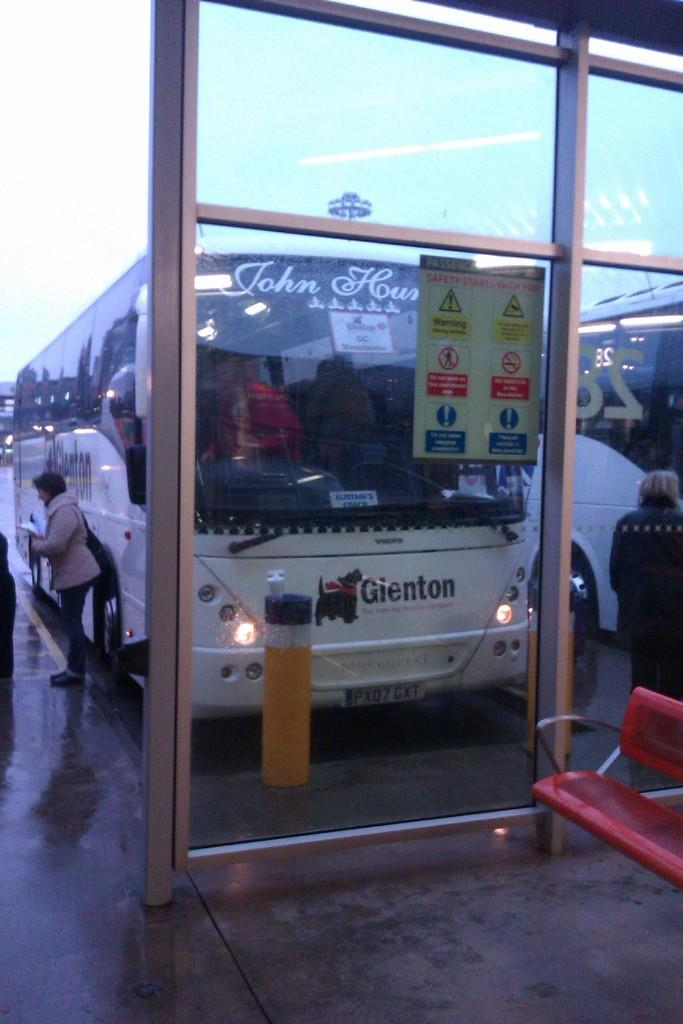What can be found in the parking space in the image? There are vehicles in the parking space in the image. What type of wall is visible in the image? There is a glass wall in the image. What type of seating is present in the image? There is a bench in the image. Who is the expert on the bench in the image? There is no expert present on the bench in the image. What type of sack is visible in the image? There is no sack present in the image. 